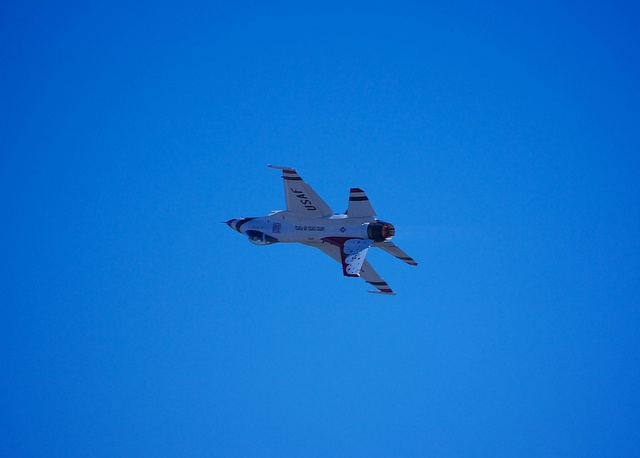Describe the objects in this image and their specific colors. I can see a airplane in blue and navy tones in this image. 